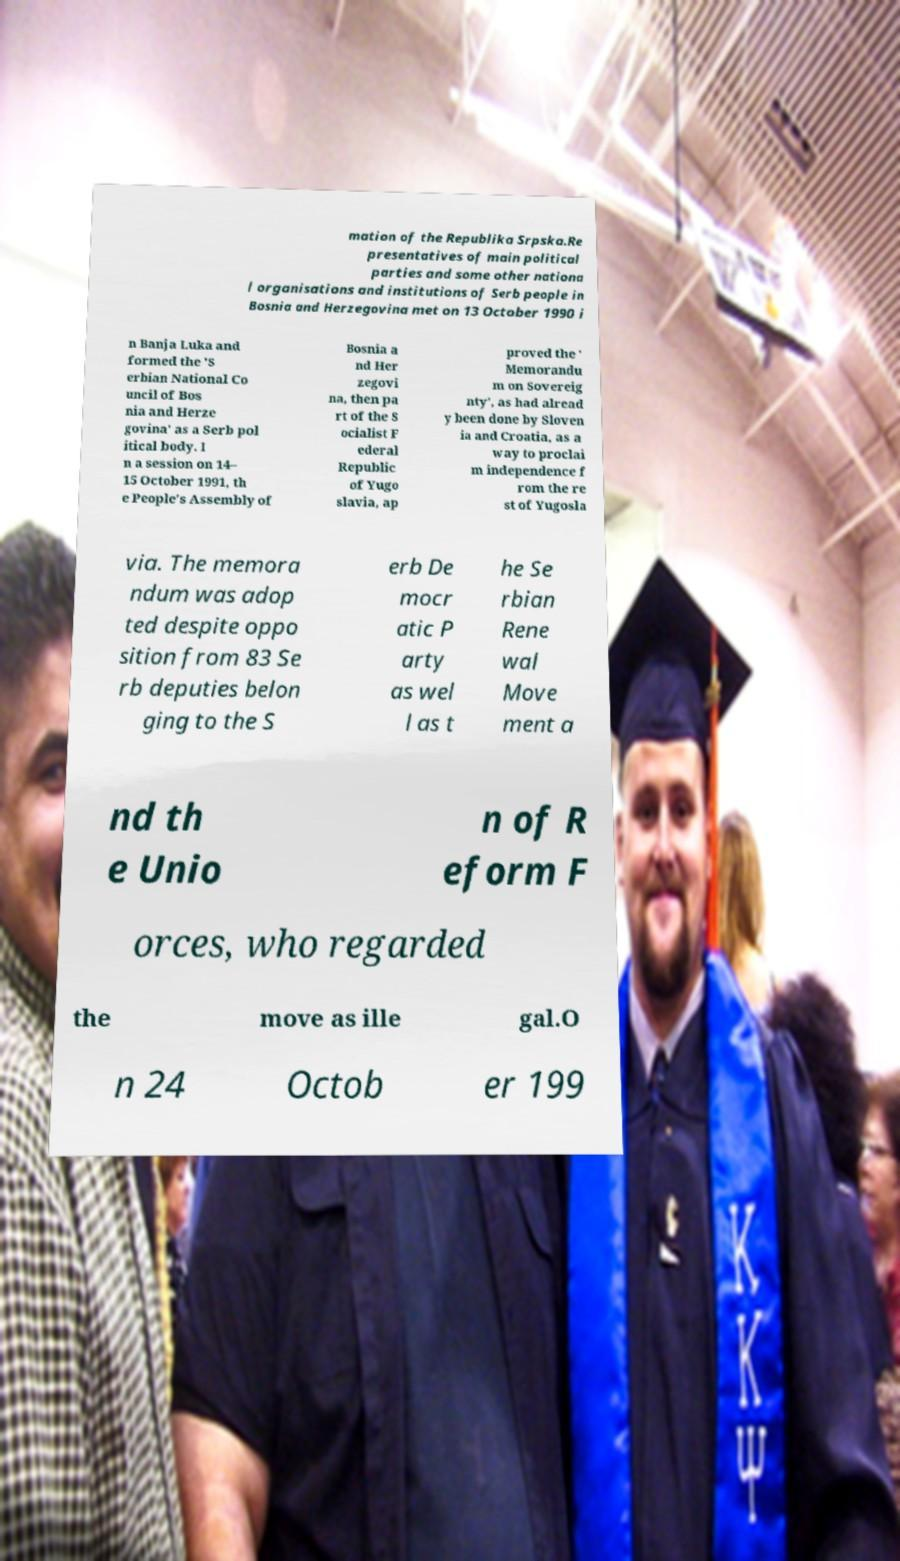What messages or text are displayed in this image? I need them in a readable, typed format. mation of the Republika Srpska.Re presentatives of main political parties and some other nationa l organisations and institutions of Serb people in Bosnia and Herzegovina met on 13 October 1990 i n Banja Luka and formed the 'S erbian National Co uncil of Bos nia and Herze govina' as a Serb pol itical body. I n a session on 14– 15 October 1991, th e People's Assembly of Bosnia a nd Her zegovi na, then pa rt of the S ocialist F ederal Republic of Yugo slavia, ap proved the ' Memorandu m on Sovereig nty', as had alread y been done by Sloven ia and Croatia, as a way to proclai m independence f rom the re st of Yugosla via. The memora ndum was adop ted despite oppo sition from 83 Se rb deputies belon ging to the S erb De mocr atic P arty as wel l as t he Se rbian Rene wal Move ment a nd th e Unio n of R eform F orces, who regarded the move as ille gal.O n 24 Octob er 199 